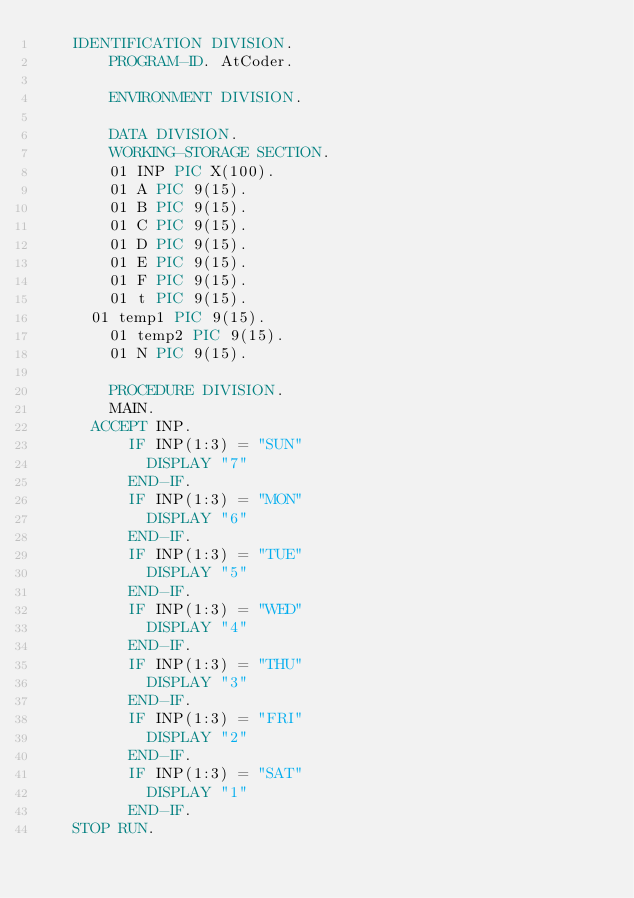Convert code to text. <code><loc_0><loc_0><loc_500><loc_500><_COBOL_>		IDENTIFICATION DIVISION.
        PROGRAM-ID. AtCoder.
      
        ENVIRONMENT DIVISION.
      
        DATA DIVISION.
        WORKING-STORAGE SECTION.
        01 INP PIC X(100).
        01 A PIC 9(15).
        01 B PIC 9(15).
        01 C PIC 9(15).
      	01 D PIC 9(15).
      	01 E PIC 9(15).
        01 F PIC 9(15).
      	01 t PIC 9(15).
	    01 temp1 PIC 9(15).
        01 temp2 PIC 9(15).
        01 N PIC 9(15).
      
        PROCEDURE DIVISION.
      	MAIN.
			ACCEPT INP.
      		IF INP(1:3) = "SUN"
      			DISPLAY "7"
      		END-IF.
      		IF INP(1:3) = "MON"
      			DISPLAY "6"
      		END-IF.
      		IF INP(1:3) = "TUE"
      			DISPLAY "5"
      		END-IF.
      		IF INP(1:3) = "WED"
      			DISPLAY "4"
      		END-IF.
      		IF INP(1:3) = "THU"
      			DISPLAY "3"
      		END-IF.
      		IF INP(1:3) = "FRI"
      			DISPLAY "2"
      		END-IF.
      		IF INP(1:3) = "SAT"
      			DISPLAY "1"
      		END-IF.
		STOP RUN.</code> 